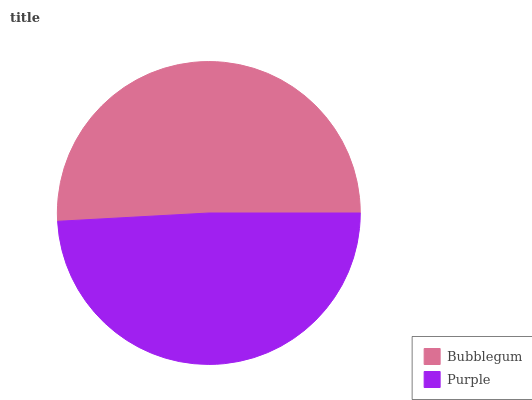Is Purple the minimum?
Answer yes or no. Yes. Is Bubblegum the maximum?
Answer yes or no. Yes. Is Purple the maximum?
Answer yes or no. No. Is Bubblegum greater than Purple?
Answer yes or no. Yes. Is Purple less than Bubblegum?
Answer yes or no. Yes. Is Purple greater than Bubblegum?
Answer yes or no. No. Is Bubblegum less than Purple?
Answer yes or no. No. Is Bubblegum the high median?
Answer yes or no. Yes. Is Purple the low median?
Answer yes or no. Yes. Is Purple the high median?
Answer yes or no. No. Is Bubblegum the low median?
Answer yes or no. No. 